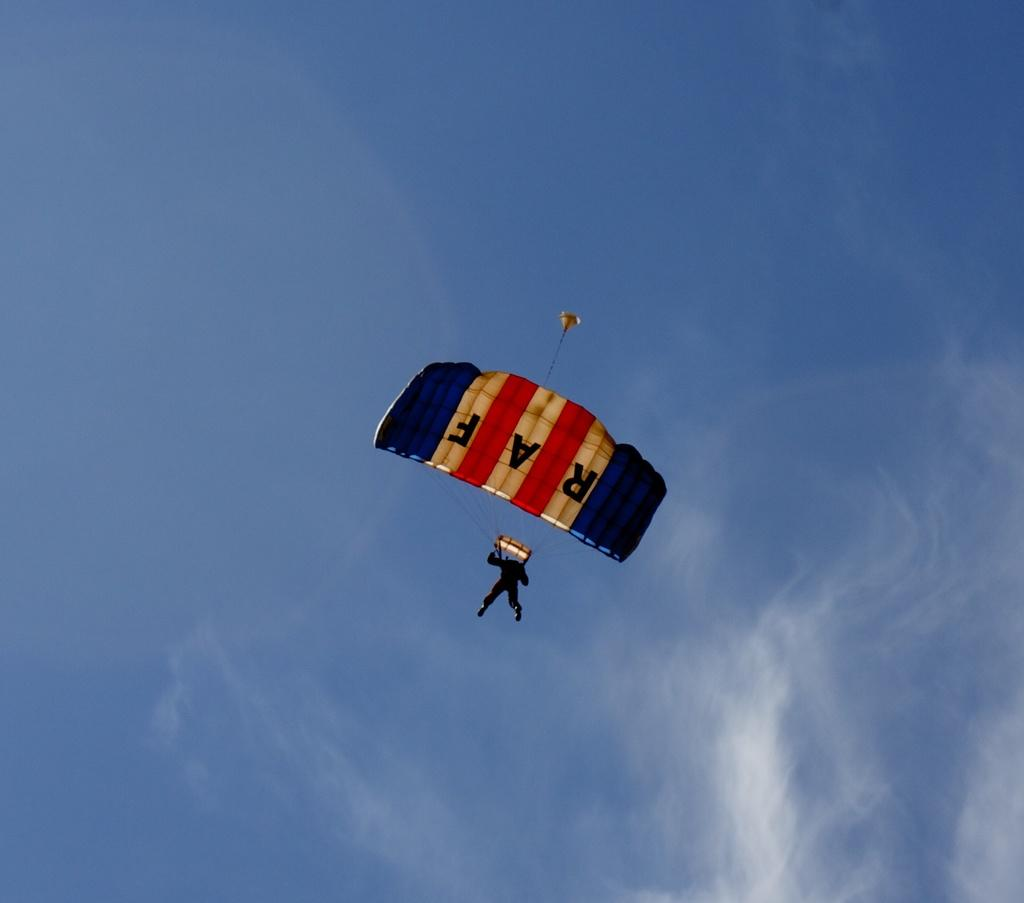<image>
Render a clear and concise summary of the photo. the person wearing the RAF parachute has jumped and is coming doen 